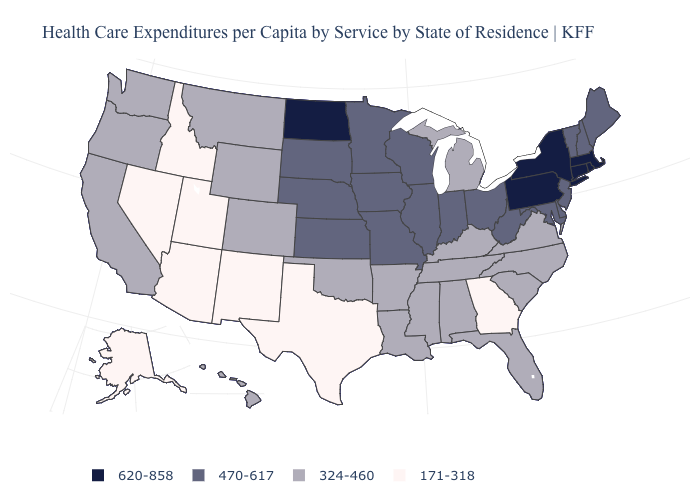What is the highest value in the West ?
Quick response, please. 324-460. What is the value of Washington?
Quick response, please. 324-460. Which states have the lowest value in the USA?
Concise answer only. Alaska, Arizona, Georgia, Idaho, Nevada, New Mexico, Texas, Utah. Does Indiana have the lowest value in the MidWest?
Answer briefly. No. Name the states that have a value in the range 620-858?
Quick response, please. Connecticut, Massachusetts, New York, North Dakota, Pennsylvania, Rhode Island. What is the value of New Hampshire?
Short answer required. 470-617. Does Rhode Island have the highest value in the Northeast?
Be succinct. Yes. Among the states that border Connecticut , which have the highest value?
Concise answer only. Massachusetts, New York, Rhode Island. What is the value of South Carolina?
Keep it brief. 324-460. Name the states that have a value in the range 171-318?
Quick response, please. Alaska, Arizona, Georgia, Idaho, Nevada, New Mexico, Texas, Utah. Does Florida have a lower value than Arkansas?
Concise answer only. No. What is the value of South Carolina?
Write a very short answer. 324-460. What is the value of North Dakota?
Short answer required. 620-858. What is the value of West Virginia?
Keep it brief. 470-617. Does North Dakota have the highest value in the USA?
Answer briefly. Yes. 